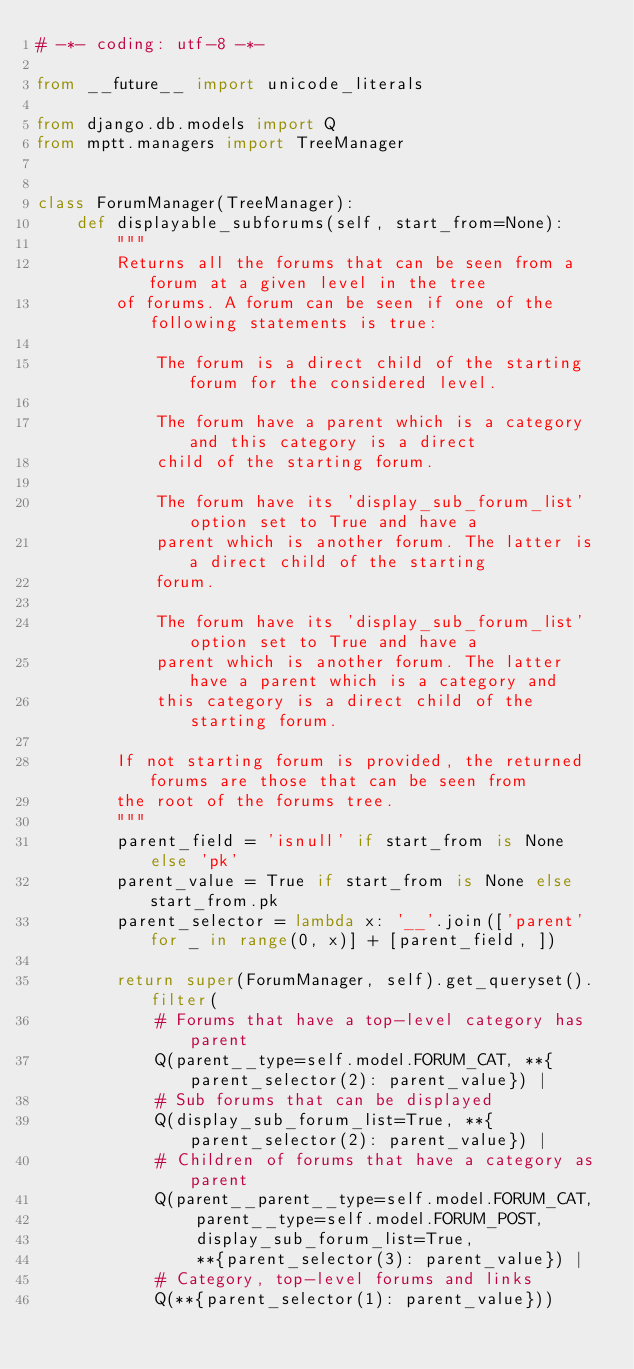Convert code to text. <code><loc_0><loc_0><loc_500><loc_500><_Python_># -*- coding: utf-8 -*-

from __future__ import unicode_literals

from django.db.models import Q
from mptt.managers import TreeManager


class ForumManager(TreeManager):
    def displayable_subforums(self, start_from=None):
        """
        Returns all the forums that can be seen from a forum at a given level in the tree
        of forums. A forum can be seen if one of the following statements is true:

            The forum is a direct child of the starting forum for the considered level.

            The forum have a parent which is a category and this category is a direct
            child of the starting forum.

            The forum have its 'display_sub_forum_list' option set to True and have a
            parent which is another forum. The latter is a direct child of the starting
            forum.

            The forum have its 'display_sub_forum_list' option set to True and have a
            parent which is another forum. The latter have a parent which is a category and
            this category is a direct child of the starting forum.

        If not starting forum is provided, the returned forums are those that can be seen from
        the root of the forums tree.
        """
        parent_field = 'isnull' if start_from is None else 'pk'
        parent_value = True if start_from is None else start_from.pk
        parent_selector = lambda x: '__'.join(['parent' for _ in range(0, x)] + [parent_field, ])

        return super(ForumManager, self).get_queryset().filter(
            # Forums that have a top-level category has parent
            Q(parent__type=self.model.FORUM_CAT, **{parent_selector(2): parent_value}) |
            # Sub forums that can be displayed
            Q(display_sub_forum_list=True, **{parent_selector(2): parent_value}) |
            # Children of forums that have a category as parent
            Q(parent__parent__type=self.model.FORUM_CAT,
                parent__type=self.model.FORUM_POST,
                display_sub_forum_list=True,
                **{parent_selector(3): parent_value}) |
            # Category, top-level forums and links
            Q(**{parent_selector(1): parent_value}))
</code> 